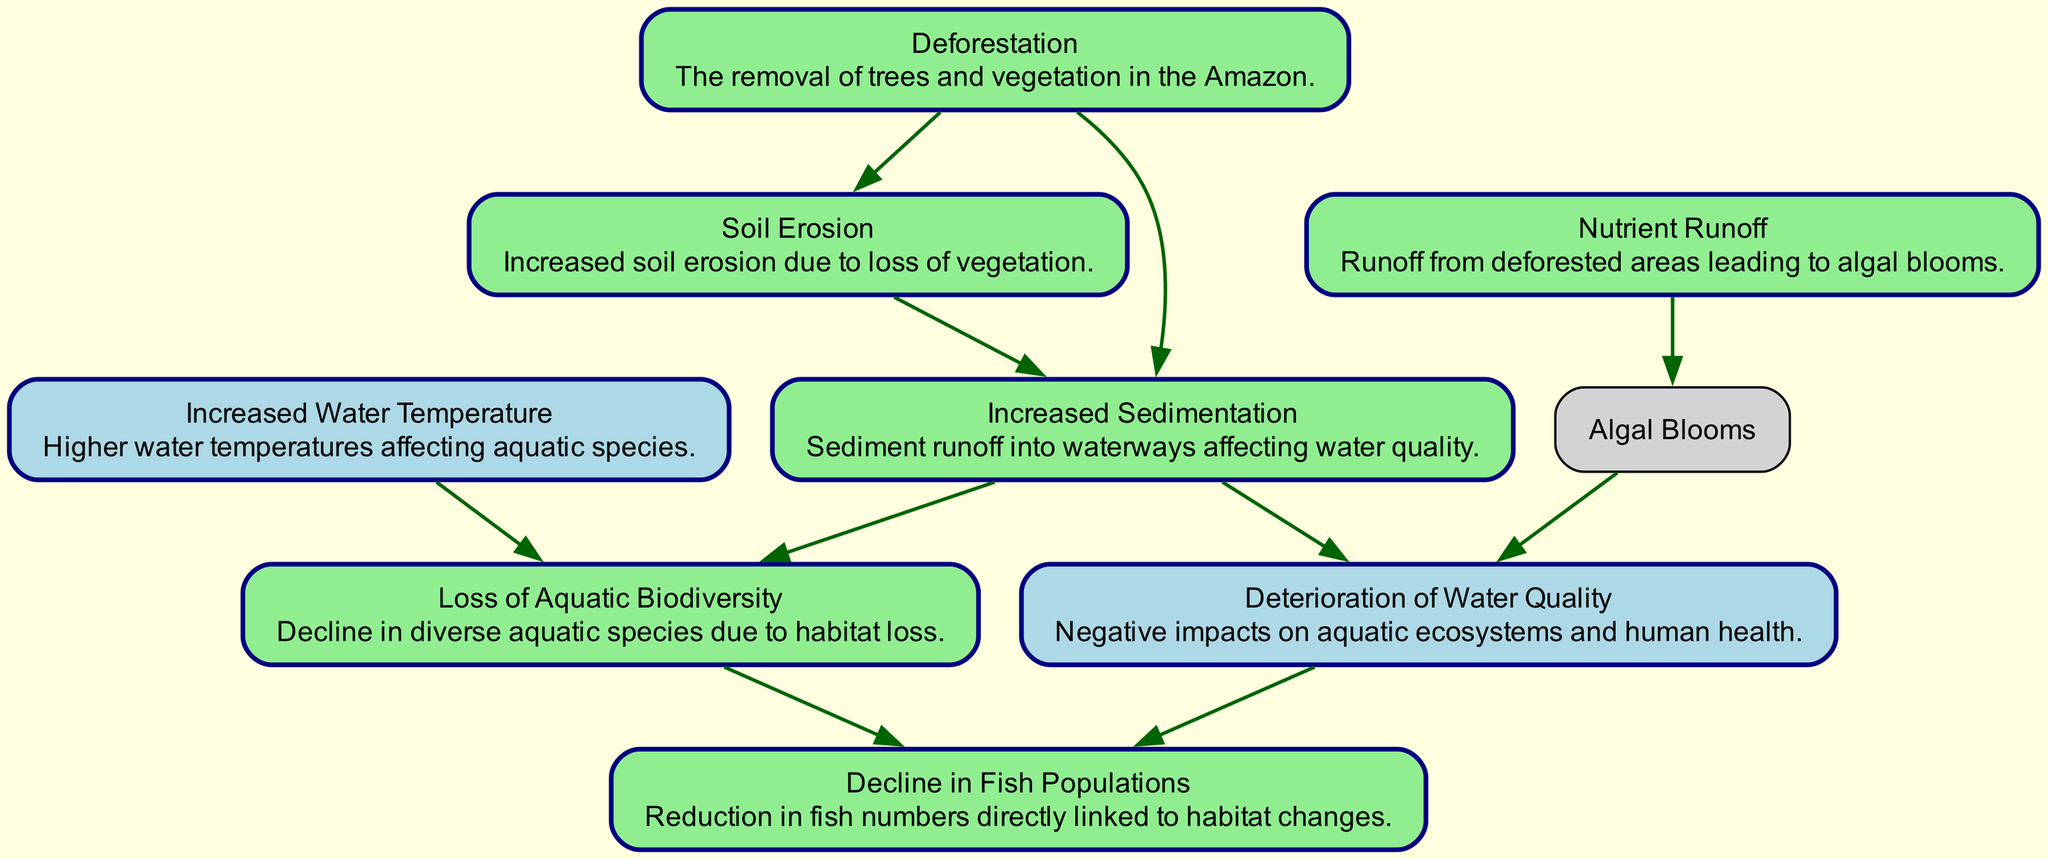What is the first node in the diagram? The first node listed in the nodes section is "Deforestation." According to the information provided, it is the initial stage impacting other elements.
Answer: Deforestation How many nodes are present in the diagram? By counting the nodes listed in the data, we find there are a total of eight nodes included in the diagram.
Answer: Eight Which nodes are directly impacted by erosion? Erosion is connected to "Sedimentation," and since erosion increases, this relationship shows that sedimentation is the direct effect. Furthermore, sedimentation leads to changes in water quality and aquatic biodiversity.
Answer: Sedimentation What is the last node in the directed graph? The last node identified in the edge connections is "Fish Populations," representing the final impact of the series of changes initiated by deforestation.
Answer: Fish Populations Which two nodes are connected via the sedimentation node? Sedimentation directly connects to "Water Quality" and "Aquatic Biodiversity," indicating that changes in sedimentation affect both these aspects.
Answer: Water Quality and Aquatic Biodiversity What type of relationship exists between nutrient runoff and water quality? The arrows in the diagram indicate that "Nutrient Runoff" leads to "Algal Blooms," which subsequently deteriorate "Water Quality," demonstrating a cause-and-effect relationship among the nodes.
Answer: Deterioration What consequence does increased water temperature have on aquatic biodiversity? Increased water temperature is shown to directly influence "Aquatic Biodiversity," suggesting that as temperatures rise, the health and variety of aquatic life are negatively impacted.
Answer: Aquatic Biodiversity How many edges are present in the diagram? By assessing the edges defined in the data set, we identify that there are ten connections showcasing the relationships among the nodes.
Answer: Ten 